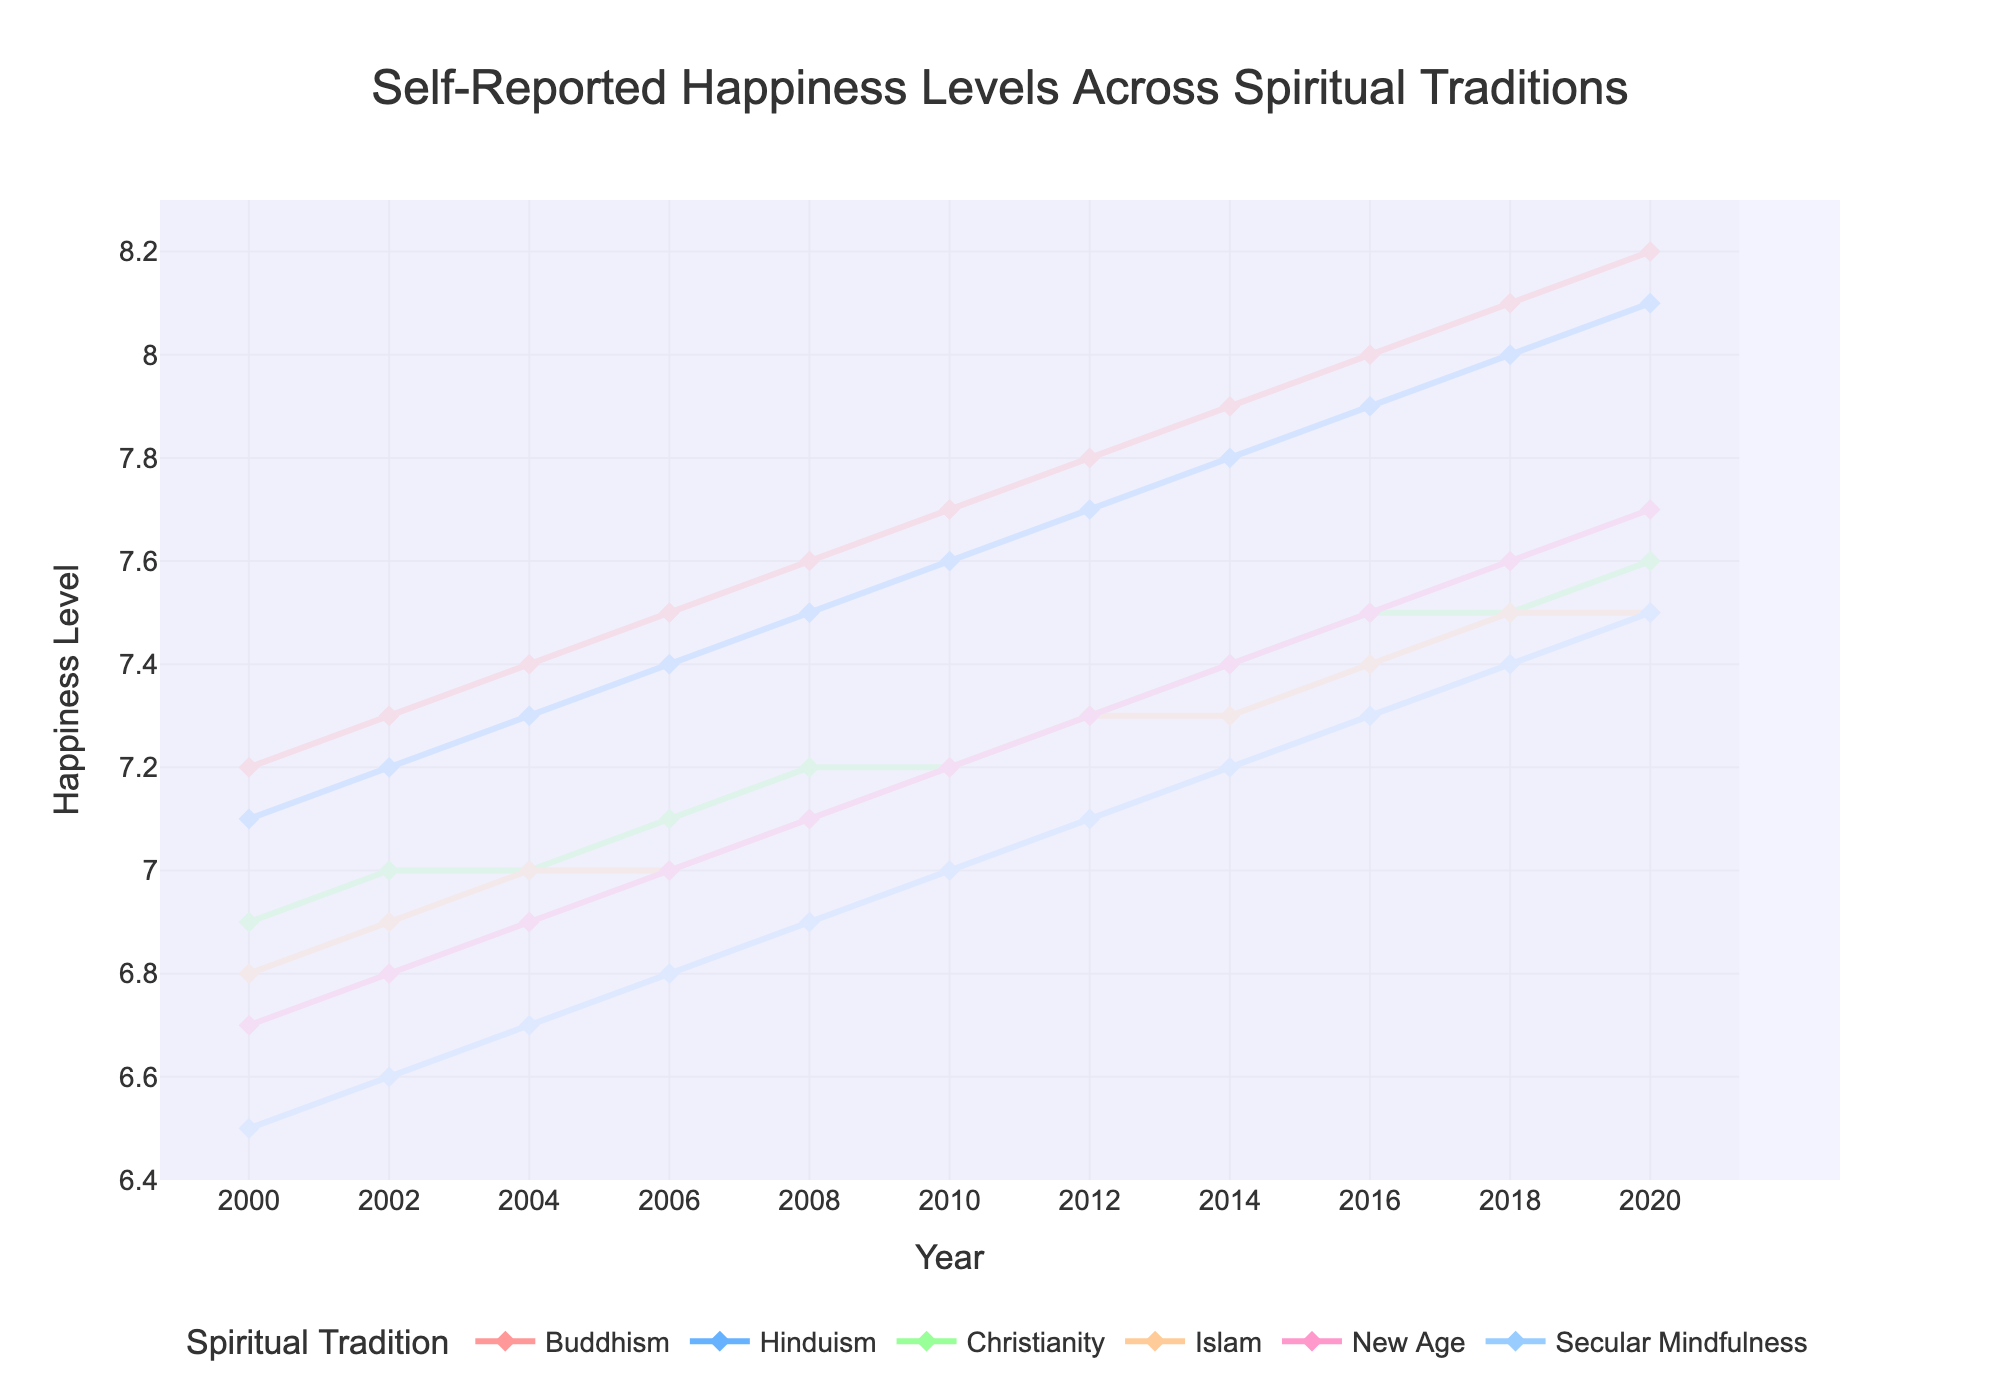What year did Buddhism and New Age report equal happiness levels? By examining the figure, we notice that the lines for Buddhism and New Age never touch or intersect, indicating they do not have the same reported happiness level in any year.
Answer: Never Which spiritual tradition showed the highest increase in self-reported happiness levels from 2000 to 2020? Calculate the difference between 2000 and 2020 happiness levels for each tradition. Buddhism: 8.2 - 7.2 = 1.0, Hinduism: 8.1 - 7.1 = 1.0, Christianity: 7.6 - 6.9 = 0.7, Islam: 7.5 - 6.8 = 0.7, New Age: 7.7 - 6.7 = 1.0, Secular Mindfulness: 7.5 - 6.5 = 1.0. Buddhism, Hinduism, New Age, and Secular Mindfulness all show an increase of 1.0, which is the highest.
Answer: Buddhism, Hinduism, New Age, Secular Mindfulness In what year did Hinduism replace Buddhism as the tradition with the highest reported happiness level? We need to examine the years when the lines of Hinduism cross above Buddhism. Observing the figure, Hinduism never surpasses Buddhism. Hence, it has never replaced Buddhism as the highest.
Answer: Never Which spiritual tradition consistently reported the lowest happiness levels across the years? By looking at the data lines, we note that Secular Mindfulness has the lowest values every year.
Answer: Secular Mindfulness What was the average self-reported happiness level for Christianity between 2000 and 2020? Summing up the values for Christianity from 2000 to 2020 and then dividing by the number of years: (6.9 + 7.0 + 7.0 + 7.1 + 7.2 + 7.2 + 7.3 + 7.4 + 7.5 + 7.5 + 7.6) / 11 = 7.18
Answer: 7.18 How many traditions had higher happiness levels than Secular Mindfulness in 2020? In 2020, Secular Mindfulness had a level of 7.5. Buddhism (8.2), Hinduism (8.1), Christianity (7.6), Islam (7.5), and New Age (7.7) are all higher or equal, making it four traditions.
Answer: 4 Which tradition had the most gradual increase in happiness levels from 2000 to 2020? A gradual increase means the least variation in rates of increase over the years. By visual examination, Secular Mindfulness shows the most evenly consistent increase.
Answer: Secular Mindfulness 